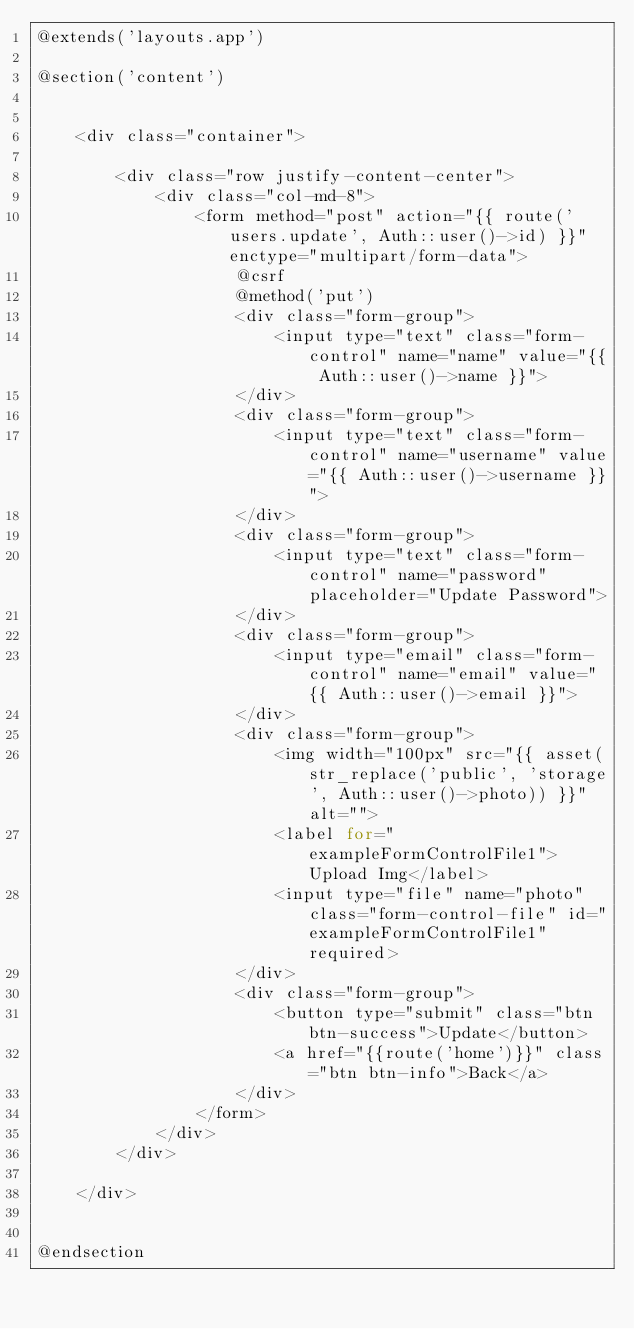Convert code to text. <code><loc_0><loc_0><loc_500><loc_500><_PHP_>@extends('layouts.app')

@section('content')


    <div class="container">

        <div class="row justify-content-center">
            <div class="col-md-8">
                <form method="post" action="{{ route('users.update', Auth::user()->id) }}" enctype="multipart/form-data">
                    @csrf
                    @method('put')
                    <div class="form-group">
                        <input type="text" class="form-control" name="name" value="{{ Auth::user()->name }}">
                    </div>
                    <div class="form-group">
                        <input type="text" class="form-control" name="username" value="{{ Auth::user()->username }}">
                    </div>
                    <div class="form-group">
                        <input type="text" class="form-control" name="password" placeholder="Update Password">
                    </div>
                    <div class="form-group">
                        <input type="email" class="form-control" name="email" value="{{ Auth::user()->email }}">
                    </div>
                    <div class="form-group">
                        <img width="100px" src="{{ asset(str_replace('public', 'storage', Auth::user()->photo)) }}" alt="">
                        <label for="exampleFormControlFile1">Upload Img</label>
                        <input type="file" name="photo" class="form-control-file" id="exampleFormControlFile1" required>
                    </div>
                    <div class="form-group">
                        <button type="submit" class="btn btn-success">Update</button>
                        <a href="{{route('home')}}" class="btn btn-info">Back</a>
                    </div>
                </form>
            </div>
        </div>

    </div>


@endsection
</code> 